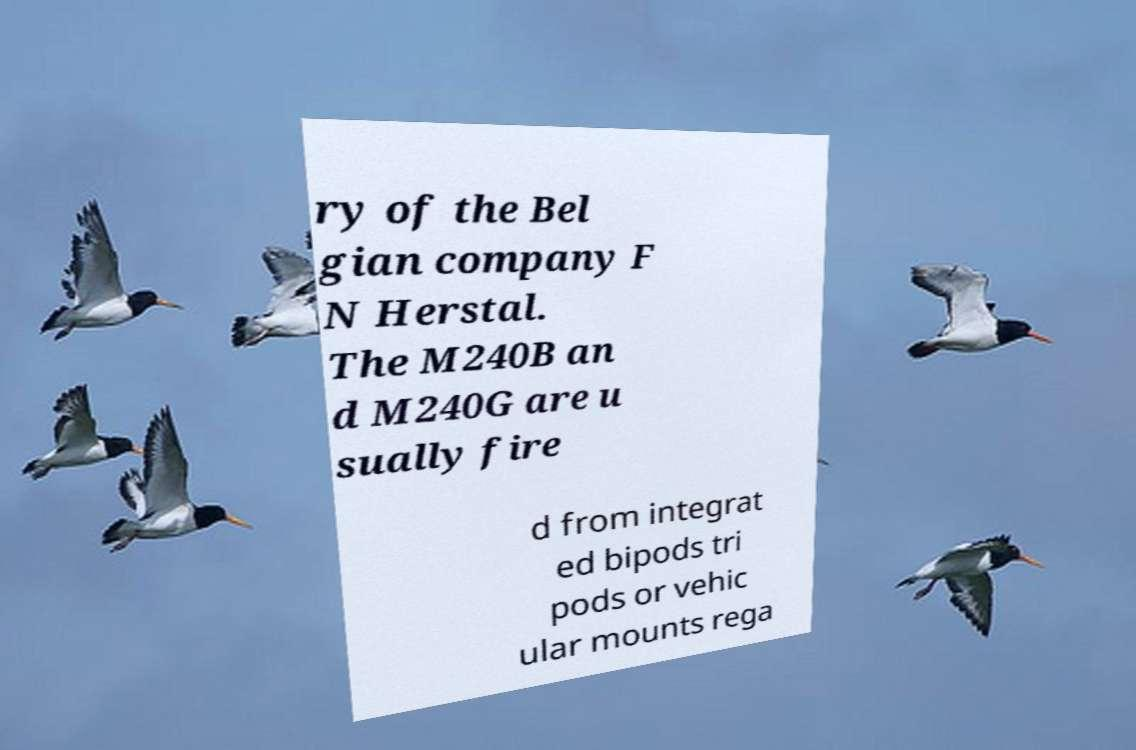What messages or text are displayed in this image? I need them in a readable, typed format. ry of the Bel gian company F N Herstal. The M240B an d M240G are u sually fire d from integrat ed bipods tri pods or vehic ular mounts rega 